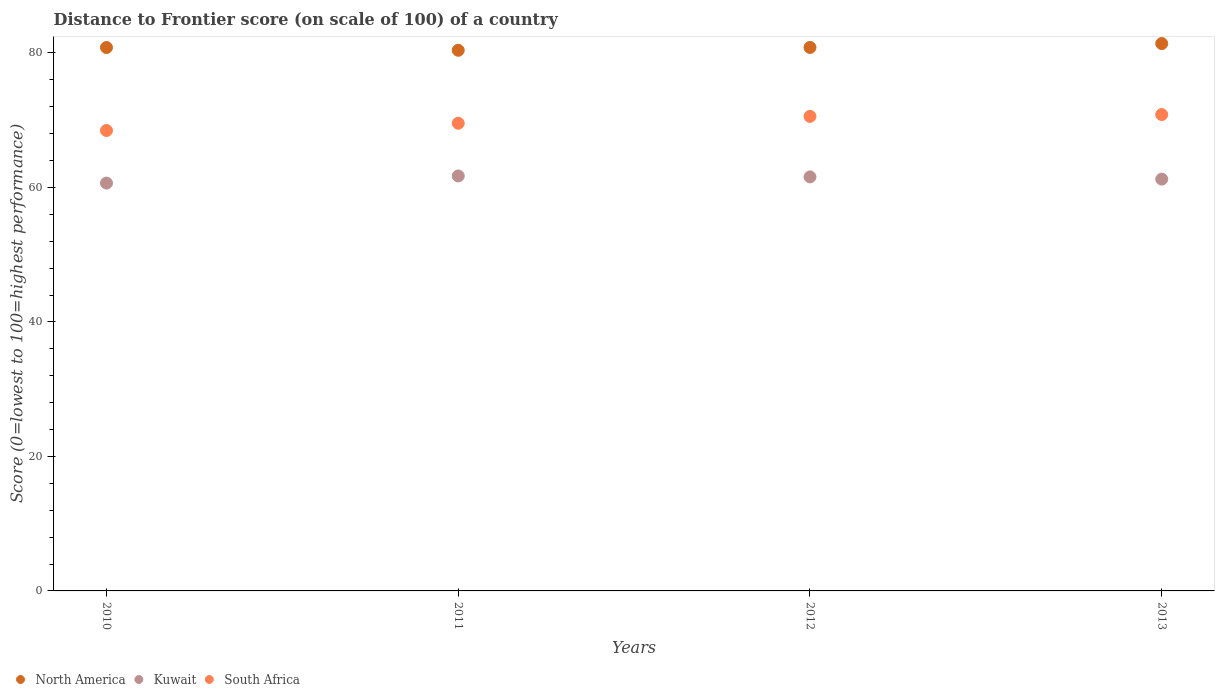How many different coloured dotlines are there?
Provide a short and direct response. 3. What is the distance to frontier score of in South Africa in 2012?
Offer a very short reply. 70.57. Across all years, what is the maximum distance to frontier score of in South Africa?
Ensure brevity in your answer.  70.84. Across all years, what is the minimum distance to frontier score of in South Africa?
Provide a short and direct response. 68.47. In which year was the distance to frontier score of in North America maximum?
Offer a terse response. 2013. In which year was the distance to frontier score of in South Africa minimum?
Ensure brevity in your answer.  2010. What is the total distance to frontier score of in South Africa in the graph?
Give a very brief answer. 279.43. What is the difference between the distance to frontier score of in Kuwait in 2010 and that in 2011?
Offer a terse response. -1.06. What is the difference between the distance to frontier score of in South Africa in 2013 and the distance to frontier score of in North America in 2010?
Ensure brevity in your answer.  -9.97. What is the average distance to frontier score of in South Africa per year?
Your answer should be compact. 69.86. In the year 2011, what is the difference between the distance to frontier score of in South Africa and distance to frontier score of in North America?
Your answer should be very brief. -10.85. What is the ratio of the distance to frontier score of in Kuwait in 2010 to that in 2011?
Keep it short and to the point. 0.98. What is the difference between the highest and the second highest distance to frontier score of in South Africa?
Keep it short and to the point. 0.27. What is the difference between the highest and the lowest distance to frontier score of in Kuwait?
Keep it short and to the point. 1.06. In how many years, is the distance to frontier score of in Kuwait greater than the average distance to frontier score of in Kuwait taken over all years?
Keep it short and to the point. 2. Is it the case that in every year, the sum of the distance to frontier score of in Kuwait and distance to frontier score of in South Africa  is greater than the distance to frontier score of in North America?
Keep it short and to the point. Yes. Does the distance to frontier score of in North America monotonically increase over the years?
Keep it short and to the point. No. Is the distance to frontier score of in Kuwait strictly greater than the distance to frontier score of in South Africa over the years?
Provide a short and direct response. No. Is the distance to frontier score of in South Africa strictly less than the distance to frontier score of in Kuwait over the years?
Keep it short and to the point. No. How many years are there in the graph?
Make the answer very short. 4. Does the graph contain any zero values?
Give a very brief answer. No. Does the graph contain grids?
Make the answer very short. No. Where does the legend appear in the graph?
Give a very brief answer. Bottom left. How many legend labels are there?
Offer a very short reply. 3. What is the title of the graph?
Offer a terse response. Distance to Frontier score (on scale of 100) of a country. Does "St. Martin (French part)" appear as one of the legend labels in the graph?
Your answer should be very brief. No. What is the label or title of the X-axis?
Make the answer very short. Years. What is the label or title of the Y-axis?
Make the answer very short. Score (0=lowest to 100=highest performance). What is the Score (0=lowest to 100=highest performance) in North America in 2010?
Provide a succinct answer. 80.81. What is the Score (0=lowest to 100=highest performance) in Kuwait in 2010?
Offer a very short reply. 60.65. What is the Score (0=lowest to 100=highest performance) of South Africa in 2010?
Provide a short and direct response. 68.47. What is the Score (0=lowest to 100=highest performance) of North America in 2011?
Provide a succinct answer. 80.4. What is the Score (0=lowest to 100=highest performance) of Kuwait in 2011?
Provide a succinct answer. 61.71. What is the Score (0=lowest to 100=highest performance) of South Africa in 2011?
Provide a succinct answer. 69.55. What is the Score (0=lowest to 100=highest performance) of North America in 2012?
Offer a very short reply. 80.82. What is the Score (0=lowest to 100=highest performance) in Kuwait in 2012?
Provide a short and direct response. 61.57. What is the Score (0=lowest to 100=highest performance) of South Africa in 2012?
Provide a succinct answer. 70.57. What is the Score (0=lowest to 100=highest performance) of North America in 2013?
Your response must be concise. 81.4. What is the Score (0=lowest to 100=highest performance) in Kuwait in 2013?
Give a very brief answer. 61.24. What is the Score (0=lowest to 100=highest performance) of South Africa in 2013?
Give a very brief answer. 70.84. Across all years, what is the maximum Score (0=lowest to 100=highest performance) of North America?
Give a very brief answer. 81.4. Across all years, what is the maximum Score (0=lowest to 100=highest performance) in Kuwait?
Give a very brief answer. 61.71. Across all years, what is the maximum Score (0=lowest to 100=highest performance) in South Africa?
Keep it short and to the point. 70.84. Across all years, what is the minimum Score (0=lowest to 100=highest performance) of North America?
Keep it short and to the point. 80.4. Across all years, what is the minimum Score (0=lowest to 100=highest performance) in Kuwait?
Keep it short and to the point. 60.65. Across all years, what is the minimum Score (0=lowest to 100=highest performance) in South Africa?
Provide a succinct answer. 68.47. What is the total Score (0=lowest to 100=highest performance) in North America in the graph?
Your response must be concise. 323.43. What is the total Score (0=lowest to 100=highest performance) of Kuwait in the graph?
Give a very brief answer. 245.17. What is the total Score (0=lowest to 100=highest performance) in South Africa in the graph?
Ensure brevity in your answer.  279.43. What is the difference between the Score (0=lowest to 100=highest performance) in North America in 2010 and that in 2011?
Offer a very short reply. 0.41. What is the difference between the Score (0=lowest to 100=highest performance) in Kuwait in 2010 and that in 2011?
Provide a short and direct response. -1.06. What is the difference between the Score (0=lowest to 100=highest performance) of South Africa in 2010 and that in 2011?
Your answer should be very brief. -1.08. What is the difference between the Score (0=lowest to 100=highest performance) in North America in 2010 and that in 2012?
Make the answer very short. -0.01. What is the difference between the Score (0=lowest to 100=highest performance) in Kuwait in 2010 and that in 2012?
Provide a succinct answer. -0.92. What is the difference between the Score (0=lowest to 100=highest performance) of South Africa in 2010 and that in 2012?
Offer a very short reply. -2.1. What is the difference between the Score (0=lowest to 100=highest performance) in North America in 2010 and that in 2013?
Give a very brief answer. -0.59. What is the difference between the Score (0=lowest to 100=highest performance) of Kuwait in 2010 and that in 2013?
Make the answer very short. -0.59. What is the difference between the Score (0=lowest to 100=highest performance) of South Africa in 2010 and that in 2013?
Offer a very short reply. -2.37. What is the difference between the Score (0=lowest to 100=highest performance) in North America in 2011 and that in 2012?
Ensure brevity in your answer.  -0.42. What is the difference between the Score (0=lowest to 100=highest performance) in Kuwait in 2011 and that in 2012?
Ensure brevity in your answer.  0.14. What is the difference between the Score (0=lowest to 100=highest performance) of South Africa in 2011 and that in 2012?
Your answer should be very brief. -1.02. What is the difference between the Score (0=lowest to 100=highest performance) in North America in 2011 and that in 2013?
Provide a short and direct response. -1. What is the difference between the Score (0=lowest to 100=highest performance) of Kuwait in 2011 and that in 2013?
Your answer should be very brief. 0.47. What is the difference between the Score (0=lowest to 100=highest performance) in South Africa in 2011 and that in 2013?
Your answer should be compact. -1.29. What is the difference between the Score (0=lowest to 100=highest performance) of North America in 2012 and that in 2013?
Your answer should be compact. -0.58. What is the difference between the Score (0=lowest to 100=highest performance) in Kuwait in 2012 and that in 2013?
Your answer should be compact. 0.33. What is the difference between the Score (0=lowest to 100=highest performance) in South Africa in 2012 and that in 2013?
Your response must be concise. -0.27. What is the difference between the Score (0=lowest to 100=highest performance) in North America in 2010 and the Score (0=lowest to 100=highest performance) in Kuwait in 2011?
Ensure brevity in your answer.  19.1. What is the difference between the Score (0=lowest to 100=highest performance) in North America in 2010 and the Score (0=lowest to 100=highest performance) in South Africa in 2011?
Give a very brief answer. 11.26. What is the difference between the Score (0=lowest to 100=highest performance) in North America in 2010 and the Score (0=lowest to 100=highest performance) in Kuwait in 2012?
Offer a terse response. 19.24. What is the difference between the Score (0=lowest to 100=highest performance) of North America in 2010 and the Score (0=lowest to 100=highest performance) of South Africa in 2012?
Provide a short and direct response. 10.24. What is the difference between the Score (0=lowest to 100=highest performance) in Kuwait in 2010 and the Score (0=lowest to 100=highest performance) in South Africa in 2012?
Your response must be concise. -9.92. What is the difference between the Score (0=lowest to 100=highest performance) of North America in 2010 and the Score (0=lowest to 100=highest performance) of Kuwait in 2013?
Keep it short and to the point. 19.57. What is the difference between the Score (0=lowest to 100=highest performance) in North America in 2010 and the Score (0=lowest to 100=highest performance) in South Africa in 2013?
Provide a short and direct response. 9.97. What is the difference between the Score (0=lowest to 100=highest performance) of Kuwait in 2010 and the Score (0=lowest to 100=highest performance) of South Africa in 2013?
Give a very brief answer. -10.19. What is the difference between the Score (0=lowest to 100=highest performance) of North America in 2011 and the Score (0=lowest to 100=highest performance) of Kuwait in 2012?
Make the answer very short. 18.83. What is the difference between the Score (0=lowest to 100=highest performance) of North America in 2011 and the Score (0=lowest to 100=highest performance) of South Africa in 2012?
Offer a terse response. 9.83. What is the difference between the Score (0=lowest to 100=highest performance) in Kuwait in 2011 and the Score (0=lowest to 100=highest performance) in South Africa in 2012?
Ensure brevity in your answer.  -8.86. What is the difference between the Score (0=lowest to 100=highest performance) in North America in 2011 and the Score (0=lowest to 100=highest performance) in Kuwait in 2013?
Provide a short and direct response. 19.16. What is the difference between the Score (0=lowest to 100=highest performance) of North America in 2011 and the Score (0=lowest to 100=highest performance) of South Africa in 2013?
Your answer should be compact. 9.56. What is the difference between the Score (0=lowest to 100=highest performance) in Kuwait in 2011 and the Score (0=lowest to 100=highest performance) in South Africa in 2013?
Your answer should be compact. -9.13. What is the difference between the Score (0=lowest to 100=highest performance) of North America in 2012 and the Score (0=lowest to 100=highest performance) of Kuwait in 2013?
Your answer should be very brief. 19.58. What is the difference between the Score (0=lowest to 100=highest performance) of North America in 2012 and the Score (0=lowest to 100=highest performance) of South Africa in 2013?
Offer a terse response. 9.98. What is the difference between the Score (0=lowest to 100=highest performance) in Kuwait in 2012 and the Score (0=lowest to 100=highest performance) in South Africa in 2013?
Your response must be concise. -9.27. What is the average Score (0=lowest to 100=highest performance) of North America per year?
Your answer should be compact. 80.86. What is the average Score (0=lowest to 100=highest performance) of Kuwait per year?
Your answer should be compact. 61.29. What is the average Score (0=lowest to 100=highest performance) in South Africa per year?
Your response must be concise. 69.86. In the year 2010, what is the difference between the Score (0=lowest to 100=highest performance) of North America and Score (0=lowest to 100=highest performance) of Kuwait?
Your answer should be very brief. 20.16. In the year 2010, what is the difference between the Score (0=lowest to 100=highest performance) of North America and Score (0=lowest to 100=highest performance) of South Africa?
Ensure brevity in your answer.  12.34. In the year 2010, what is the difference between the Score (0=lowest to 100=highest performance) in Kuwait and Score (0=lowest to 100=highest performance) in South Africa?
Make the answer very short. -7.82. In the year 2011, what is the difference between the Score (0=lowest to 100=highest performance) of North America and Score (0=lowest to 100=highest performance) of Kuwait?
Ensure brevity in your answer.  18.69. In the year 2011, what is the difference between the Score (0=lowest to 100=highest performance) of North America and Score (0=lowest to 100=highest performance) of South Africa?
Provide a succinct answer. 10.85. In the year 2011, what is the difference between the Score (0=lowest to 100=highest performance) of Kuwait and Score (0=lowest to 100=highest performance) of South Africa?
Offer a terse response. -7.84. In the year 2012, what is the difference between the Score (0=lowest to 100=highest performance) of North America and Score (0=lowest to 100=highest performance) of Kuwait?
Offer a very short reply. 19.25. In the year 2012, what is the difference between the Score (0=lowest to 100=highest performance) in North America and Score (0=lowest to 100=highest performance) in South Africa?
Your answer should be very brief. 10.25. In the year 2012, what is the difference between the Score (0=lowest to 100=highest performance) in Kuwait and Score (0=lowest to 100=highest performance) in South Africa?
Give a very brief answer. -9. In the year 2013, what is the difference between the Score (0=lowest to 100=highest performance) in North America and Score (0=lowest to 100=highest performance) in Kuwait?
Ensure brevity in your answer.  20.16. In the year 2013, what is the difference between the Score (0=lowest to 100=highest performance) in North America and Score (0=lowest to 100=highest performance) in South Africa?
Your response must be concise. 10.56. What is the ratio of the Score (0=lowest to 100=highest performance) of North America in 2010 to that in 2011?
Make the answer very short. 1.01. What is the ratio of the Score (0=lowest to 100=highest performance) in Kuwait in 2010 to that in 2011?
Ensure brevity in your answer.  0.98. What is the ratio of the Score (0=lowest to 100=highest performance) in South Africa in 2010 to that in 2011?
Your answer should be very brief. 0.98. What is the ratio of the Score (0=lowest to 100=highest performance) in Kuwait in 2010 to that in 2012?
Your response must be concise. 0.99. What is the ratio of the Score (0=lowest to 100=highest performance) in South Africa in 2010 to that in 2012?
Offer a terse response. 0.97. What is the ratio of the Score (0=lowest to 100=highest performance) of South Africa in 2010 to that in 2013?
Your answer should be very brief. 0.97. What is the ratio of the Score (0=lowest to 100=highest performance) of Kuwait in 2011 to that in 2012?
Provide a short and direct response. 1. What is the ratio of the Score (0=lowest to 100=highest performance) in South Africa in 2011 to that in 2012?
Provide a succinct answer. 0.99. What is the ratio of the Score (0=lowest to 100=highest performance) of North America in 2011 to that in 2013?
Your response must be concise. 0.99. What is the ratio of the Score (0=lowest to 100=highest performance) in Kuwait in 2011 to that in 2013?
Keep it short and to the point. 1.01. What is the ratio of the Score (0=lowest to 100=highest performance) of South Africa in 2011 to that in 2013?
Give a very brief answer. 0.98. What is the ratio of the Score (0=lowest to 100=highest performance) in North America in 2012 to that in 2013?
Your answer should be compact. 0.99. What is the ratio of the Score (0=lowest to 100=highest performance) in Kuwait in 2012 to that in 2013?
Make the answer very short. 1.01. What is the difference between the highest and the second highest Score (0=lowest to 100=highest performance) in North America?
Your answer should be very brief. 0.58. What is the difference between the highest and the second highest Score (0=lowest to 100=highest performance) of Kuwait?
Offer a terse response. 0.14. What is the difference between the highest and the second highest Score (0=lowest to 100=highest performance) of South Africa?
Make the answer very short. 0.27. What is the difference between the highest and the lowest Score (0=lowest to 100=highest performance) of Kuwait?
Your answer should be very brief. 1.06. What is the difference between the highest and the lowest Score (0=lowest to 100=highest performance) of South Africa?
Provide a short and direct response. 2.37. 